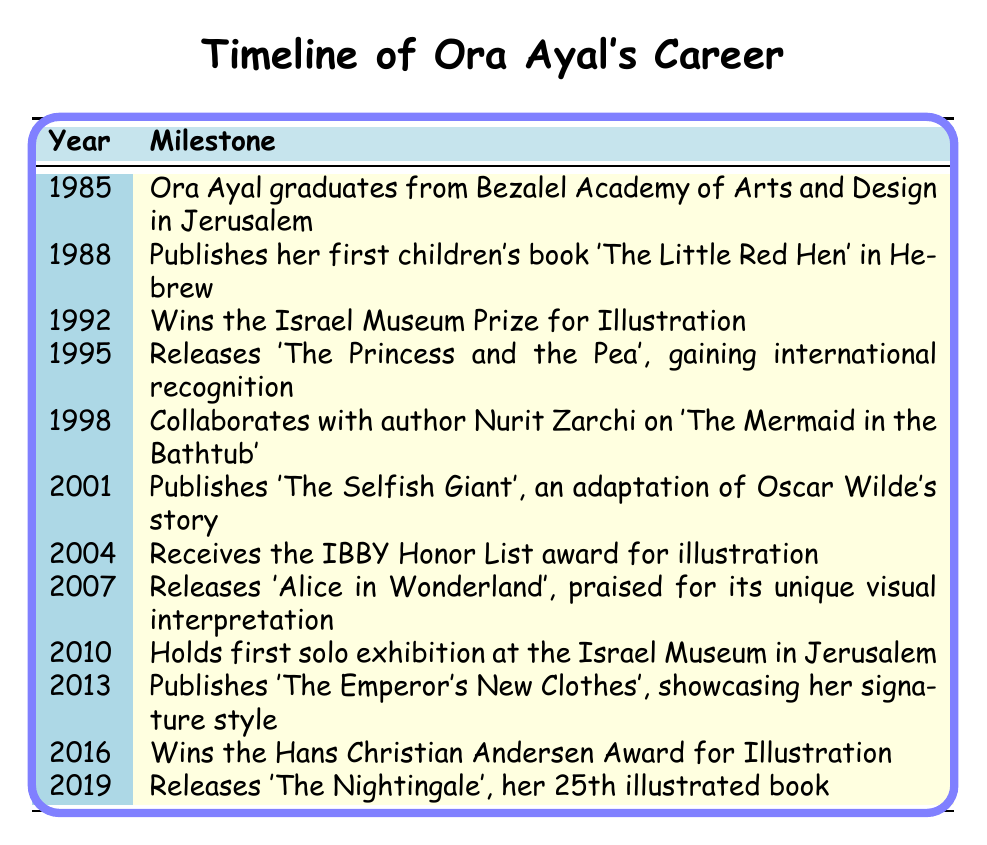What year did Ora Ayal graduate from Bezalel Academy of Arts and Design? According to the table, Ora Ayal graduated in the year 1985.
Answer: 1985 Which book did Ora Ayal publish in 1988? The table lists "The Little Red Hen" as the book published by Ora Ayal in 1988.
Answer: The Little Red Hen How many years passed between Ora Ayal's graduation and her first published book? Ora Ayal graduated in 1985 and published her first book in 1988, which is a span of 3 years (1988 - 1985 = 3).
Answer: 3 years Did Ora Ayal win the Israel Museum Prize for Illustration before or after publishing 'The Princess and the Pea'? The table shows she won the Israel Museum Prize in 1992, and published 'The Princess and the Pea' in 1995. Thus, she won the prize before.
Answer: Before What is the total number of books mentioned in the timeline? The table lists 12 milestones, out of which 10 are book releases, so the total number of books is 10.
Answer: 10 books In what year did Ora Ayal win the Hans Christian Andersen Award for Illustration? The table indicates that Ora Ayal won this award in 2016.
Answer: 2016 Which book marks Ora Ayal's 25th illustrated book? The table states that "The Nightingale" is her 25th illustrated book released in 2019.
Answer: The Nightingale Was there a span of more than 10 years between 1995 and 2016 for major milestones in Ora Ayal's career? The span from 1995 to 2016 is 21 years (2016 - 1995 = 21), thus it is more than 10 years.
Answer: Yes What milestone occurred in 2010? The table notes that in 2010, Ora Ayal held her first solo exhibition at the Israel Museum in Jerusalem.
Answer: First solo exhibition List the milestones that happened in the 1990s. The milestones in the 1990s are: 1992 - Wins the Israel Museum Prize, 1995 - Releases 'The Princess and the Pea', 1998 - Collaborates on 'The Mermaid in the Bathtub', totaling 3 milestones.
Answer: 3 milestones 